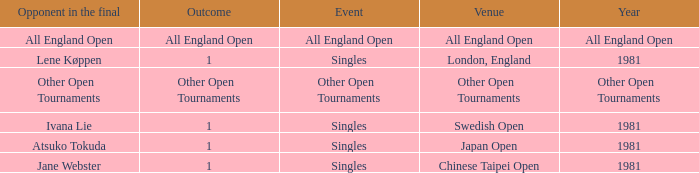What is the Outcome of the Singles Event in London, England? 1.0. 